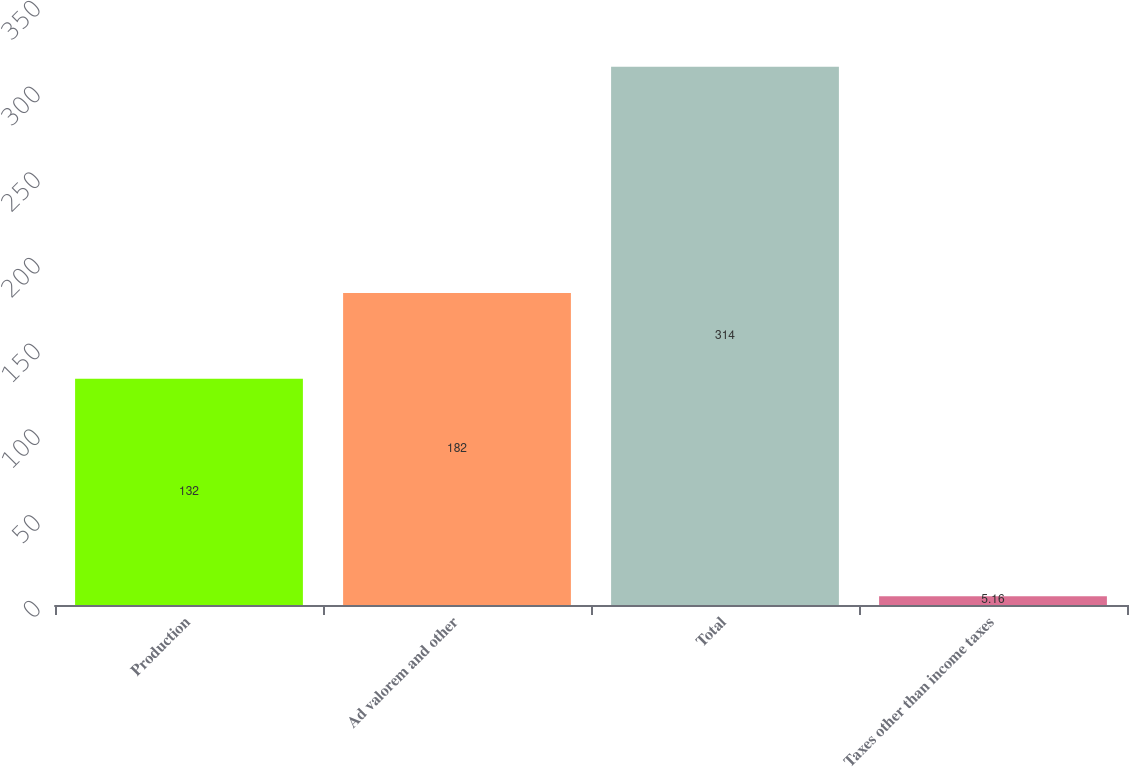Convert chart. <chart><loc_0><loc_0><loc_500><loc_500><bar_chart><fcel>Production<fcel>Ad valorem and other<fcel>Total<fcel>Taxes other than income taxes<nl><fcel>132<fcel>182<fcel>314<fcel>5.16<nl></chart> 